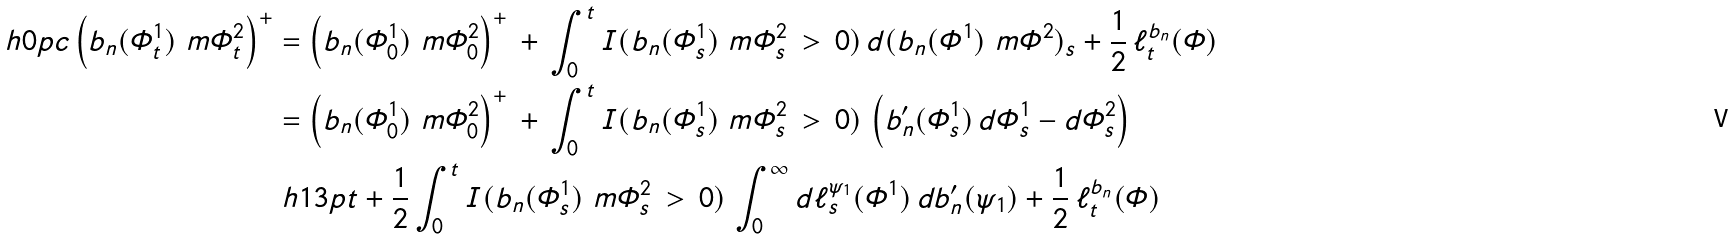<formula> <loc_0><loc_0><loc_500><loc_500>\ h { 0 p c } \left ( b _ { n } ( \varPhi _ { t } ^ { 1 } ) \ m \varPhi _ { t } ^ { 2 } \right ) ^ { + } & = \left ( b _ { n } ( \varPhi _ { 0 } ^ { 1 } ) \ m \varPhi _ { 0 } ^ { 2 } \right ) ^ { + } \, + \, \int _ { 0 } ^ { t } I ( b _ { n } ( \varPhi _ { s } ^ { 1 } ) \ m \varPhi _ { s } ^ { 2 } \, > \, 0 ) \, d ( b _ { n } ( \varPhi ^ { 1 } ) \ m \varPhi ^ { 2 } ) _ { s } + \frac { 1 } { 2 } \, \ell _ { t } ^ { b _ { n } } ( \varPhi ) \\ & = \left ( b _ { n } ( \varPhi _ { 0 } ^ { 1 } ) \ m \varPhi _ { 0 } ^ { 2 } \right ) ^ { + } \, + \, \int _ { 0 } ^ { t } I ( b _ { n } ( \varPhi _ { s } ^ { 1 } ) \ m \varPhi _ { s } ^ { 2 } \, > \, 0 ) \, \left ( b _ { n } ^ { \prime } ( \varPhi _ { s } ^ { 1 } ) \, d \varPhi _ { s } ^ { 1 } - d \varPhi _ { s } ^ { 2 } \right ) \\ & \ h { 1 3 p t } + \frac { 1 } { 2 } \int _ { 0 } ^ { t } I ( b _ { n } ( \varPhi _ { s } ^ { 1 } ) \ m \varPhi _ { s } ^ { 2 } \, > \, 0 ) \, \int _ { 0 } ^ { \infty } d \ell _ { s } ^ { \psi _ { 1 } } ( \varPhi ^ { 1 } ) \, d b _ { n } ^ { \prime } ( \psi _ { 1 } ) + \frac { 1 } { 2 } \, \ell _ { t } ^ { b _ { n } } ( \varPhi )</formula> 